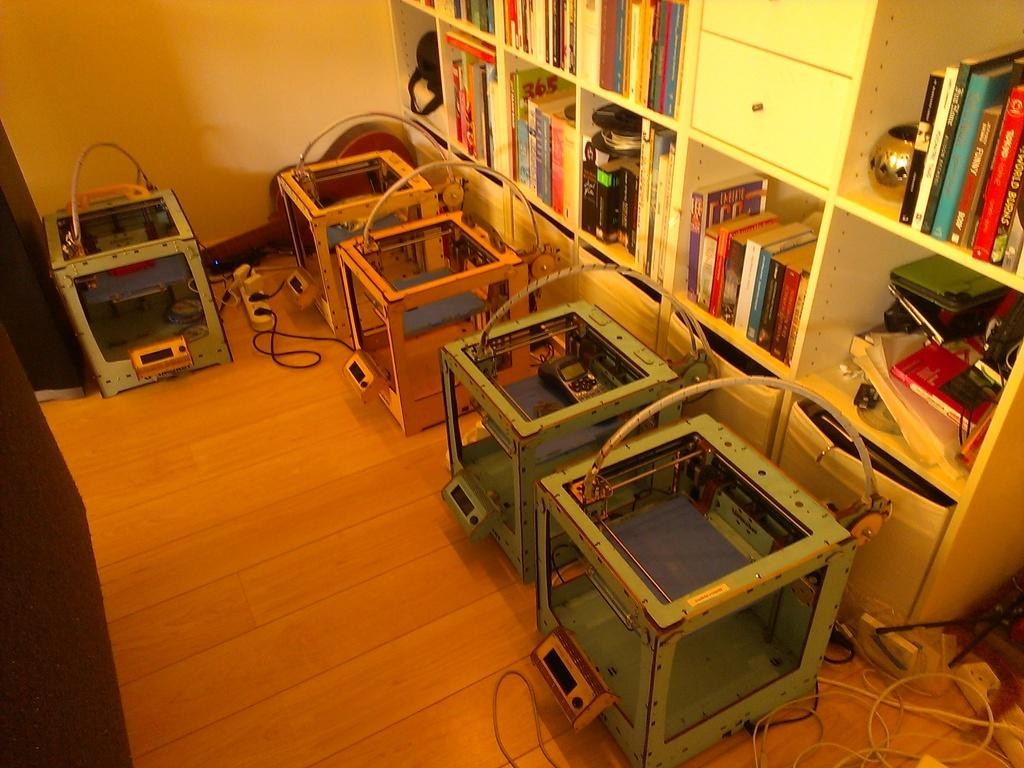What type of objects can be seen in the image? There are many machinery objects and cables in the image. Are there any electrical components visible in the image? Yes, extension boxes on the ground can be seen in the image. What type of storage is present in the image? There are books on shelves in the image. What else can be found on the shelves besides books? There are objects placed on the shelves in the image. What type of patch is visible on the elbow of the person in the image? There is no person present in the image, so there is no elbow or patch visible. 